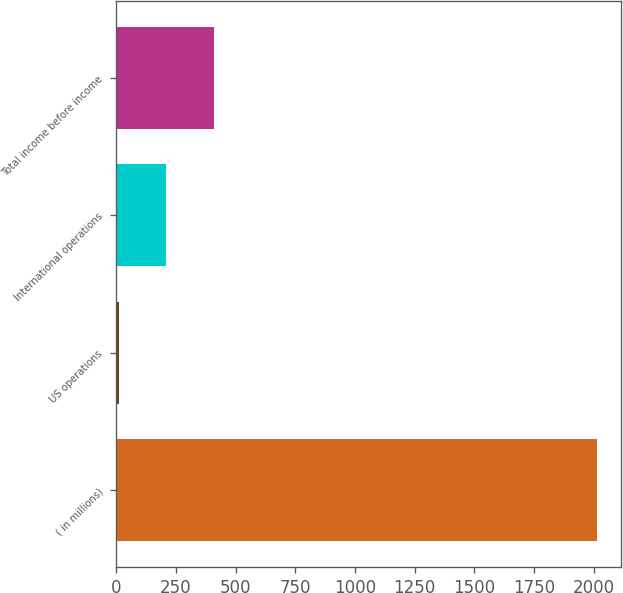Convert chart. <chart><loc_0><loc_0><loc_500><loc_500><bar_chart><fcel>( in millions)<fcel>US operations<fcel>International operations<fcel>Total income before income<nl><fcel>2012<fcel>8.9<fcel>209.21<fcel>409.52<nl></chart> 